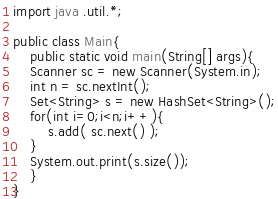<code> <loc_0><loc_0><loc_500><loc_500><_Java_>import java .util.*;

public class Main{
    public static void main(String[] args){
	Scanner sc = new Scanner(System.in);
	int n = sc.nextInt();
	Set<String> s = new HashSet<String>();
	for(int i=0;i<n;i++){
	    s.add( sc.next() );
	}
	System.out.print(s.size());
    }
}
</code> 